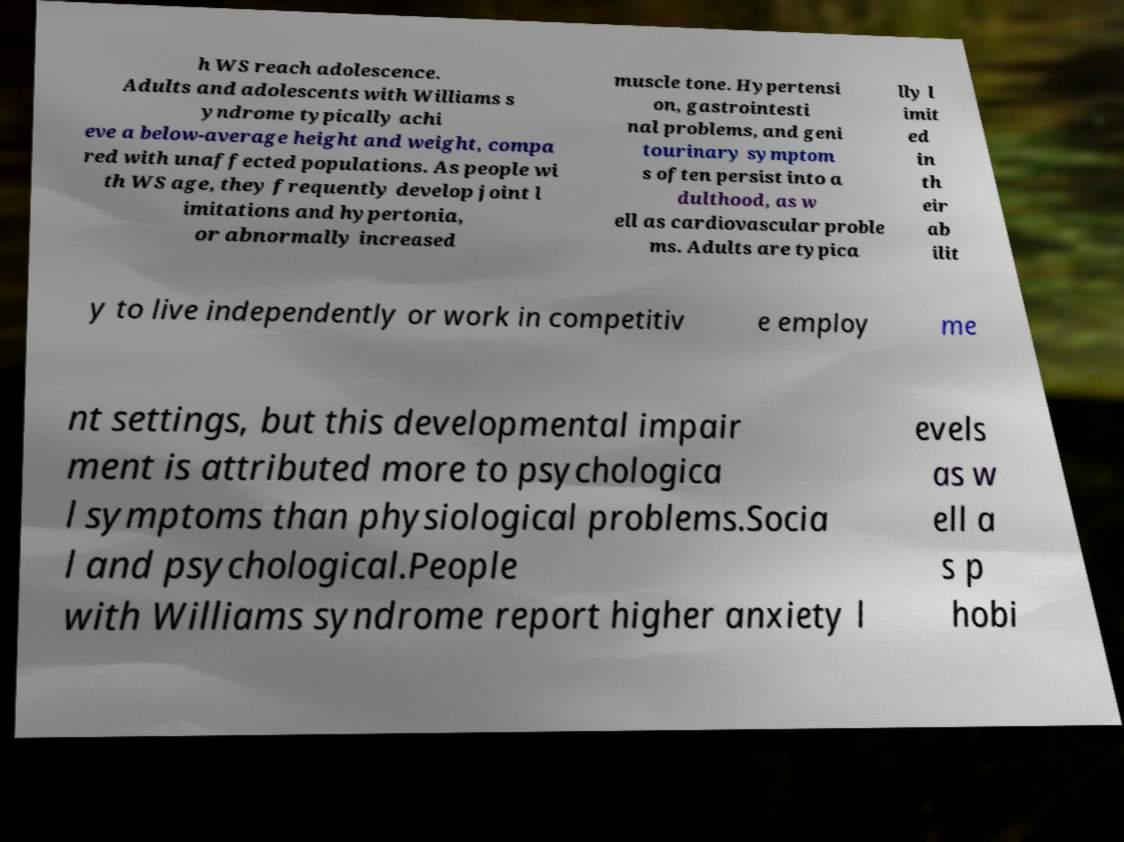Can you accurately transcribe the text from the provided image for me? h WS reach adolescence. Adults and adolescents with Williams s yndrome typically achi eve a below-average height and weight, compa red with unaffected populations. As people wi th WS age, they frequently develop joint l imitations and hypertonia, or abnormally increased muscle tone. Hypertensi on, gastrointesti nal problems, and geni tourinary symptom s often persist into a dulthood, as w ell as cardiovascular proble ms. Adults are typica lly l imit ed in th eir ab ilit y to live independently or work in competitiv e employ me nt settings, but this developmental impair ment is attributed more to psychologica l symptoms than physiological problems.Socia l and psychological.People with Williams syndrome report higher anxiety l evels as w ell a s p hobi 